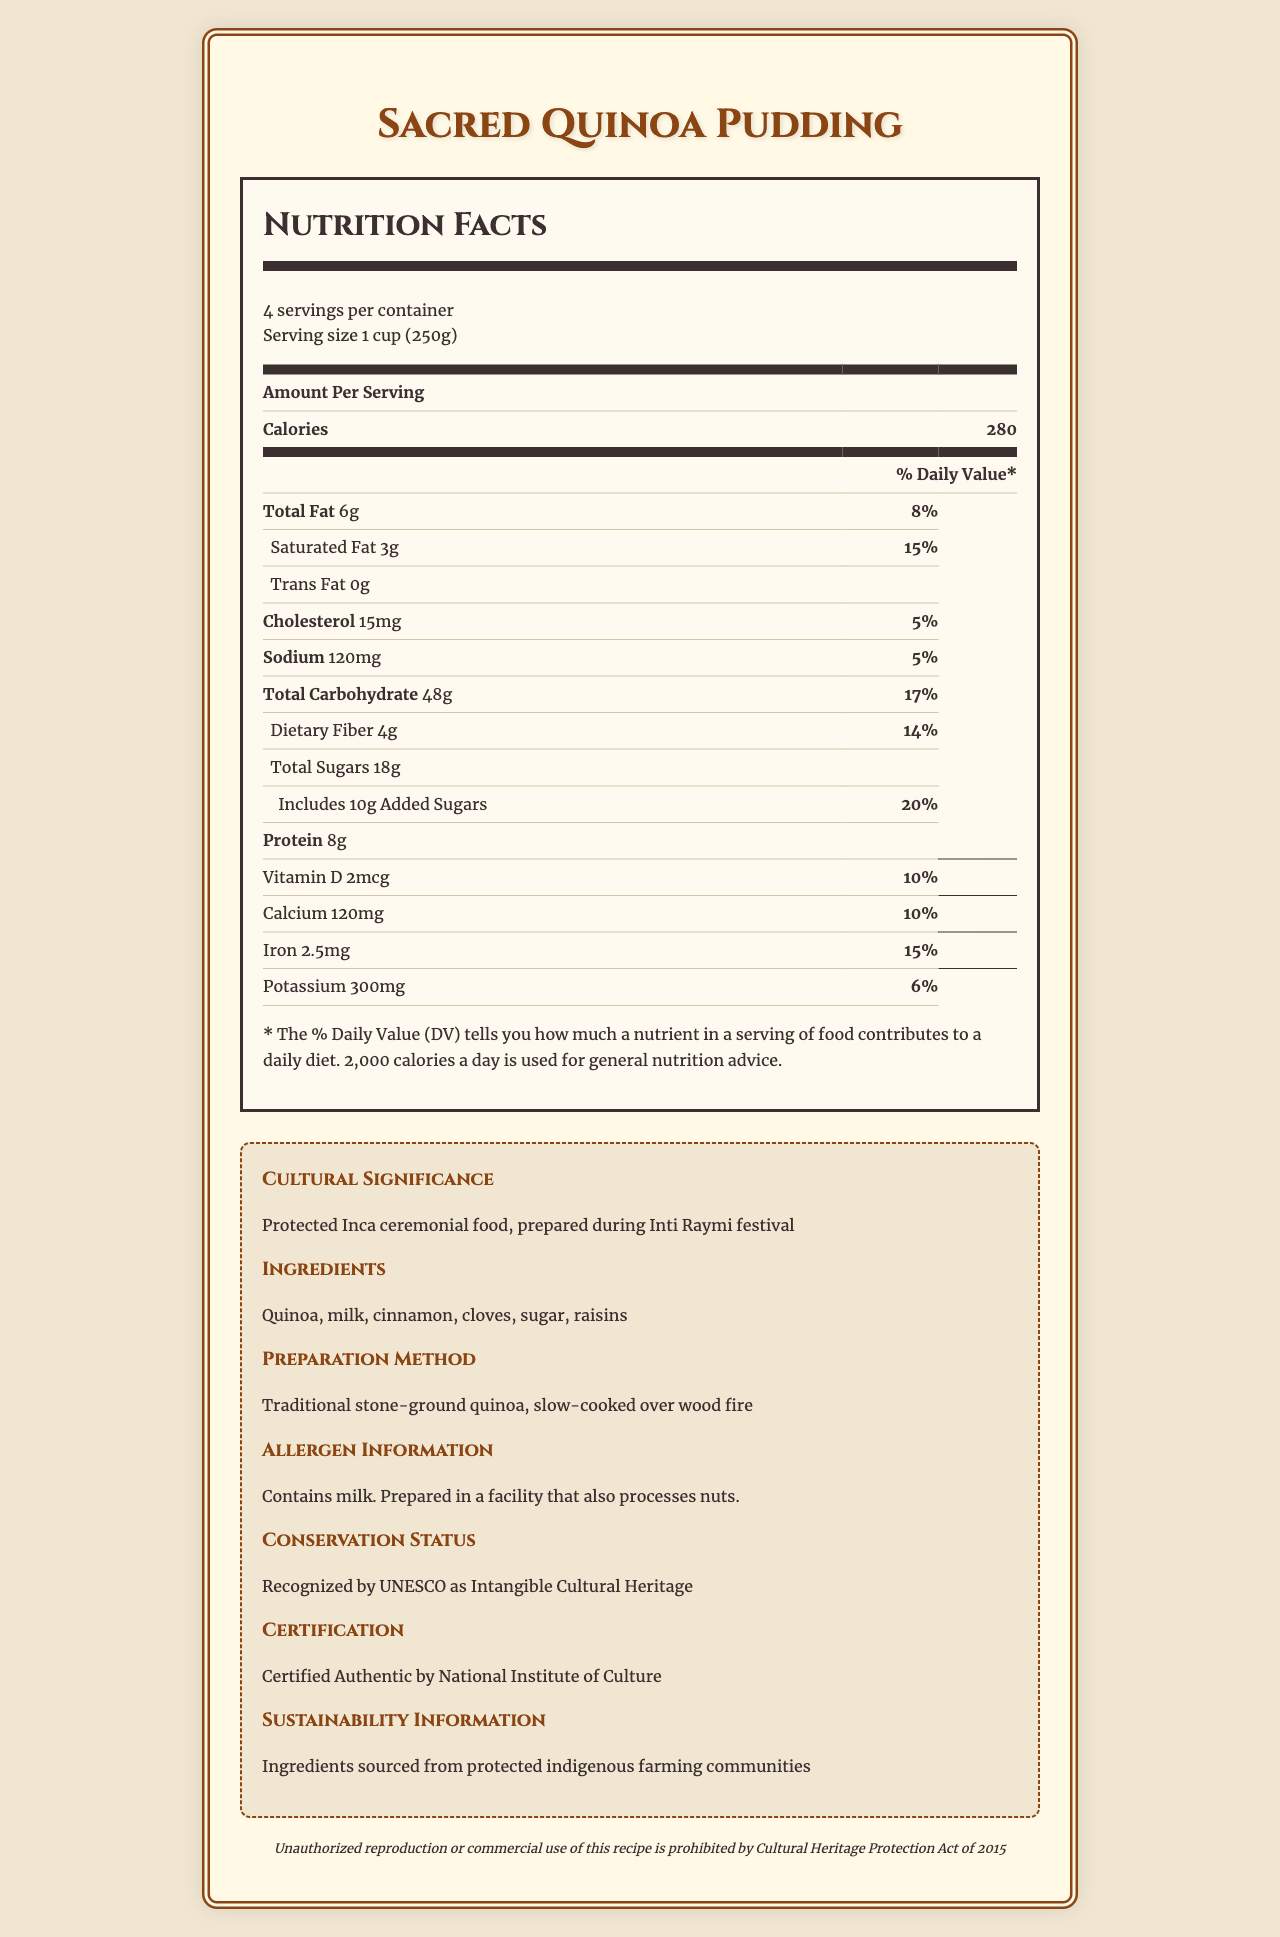what is the product name? The product name is highlighted at the top of the document.
Answer: Sacred Quinoa Pudding how many servings per container? The document specifies that there are 4 servings per container.
Answer: 4 what is the serving size? The serving size is indicated right below the number of servings per container.
Answer: 1 cup (250g) what is the amount of calories per serving? The calories per serving are listed under "Amount Per Serving".
Answer: 280 how much protein is in one serving? The protein content is listed in the nutrition label under "Protein".
Answer: 8g what is the daily value percentage of saturated fat? A. 8% B. 15% C. 5% The document lists the daily value percentage for saturated fat as 15%.
Answer: B. 15% what is the main ingredient in Sacred Quinoa Pudding? A. Rice B. Quinoa C. Wheat The main ingredient is Quinoa, which is mentioned first in the ingredients list.
Answer: B. Quinoa does this food contain trans fat? The trans fat amount listed is 0g, indicating that the food does not contain trans fat.
Answer: No is the Sacred Quinoa Pudding recognized by UNESCO? The document states that this food is recognized by UNESCO as Intangible Cultural Heritage.
Answer: Yes summarize the content of the document. The document contains a detailed nutrition label, cultural significance notes, preparation methods, allergen info, UNESCO recognition, certification, and legal use notice.
Answer: The document provides nutrition facts and cultural information about Sacred Quinoa Pudding, including serving size, calories, macronutrients, vitamins and minerals, ingredients, preparation method, allergen information, conservation status, certification, and a legal notice. what is the total weight of the pudding in one container? Since each serving is 250g and there are 4 servings per container, the total weight is 250g * 4 = 1000g or 1 kg.
Answer: 1 kg how is the quinoa prepared in Sacred Quinoa Pudding? The preparation method of the quinoa is noted in the cultural information section of the document.
Answer: Traditional stone-ground quinoa, slow-cooked over wood fire what dietary fiber content does one serving provide in grams? The document lists the dietary fiber content as 4g per serving.
Answer: 4g how much calcium is in one serving? The amount of calcium per serving is listed as 120 mg.
Answer: 120 mg what is the percentage of daily value for added sugars? In the nutrition label, added sugars provide 20% of the daily value.
Answer: 20% who provides the certification for the authenticity of Sacred Quinoa Pudding? The certification section lists the National Institute of Culture as the certifying body.
Answer: National Institute of Culture does the Sacred Quinoa Pudding contain nuts? The allergen information indicates that while the pudding itself does not contain nuts, it is prepared in a facility that also processes nuts.
Answer: Not directly, but it is prepared in a facility that processes nuts how many grams of sugar are in a serving? The total sugars per serving are specified as 18g in the nutrition label.
Answer: 18g what farming communities are the ingredients sourced from? The sustainability information mentions that the ingredients are sourced from protected indigenous farming communities.
Answer: Protected indigenous farming communities what is the Cultural Heritage Protection Act year mentioned in the document? The legal notice specifies the Cultural Heritage Protection Act of 2015.
Answer: 2015 what are the environmental impacts of producing Sacred Quinoa Pudding? The document specifies the sustainability of sourcing but provides no details on the broader environmental impacts of production.
Answer: Not enough information 